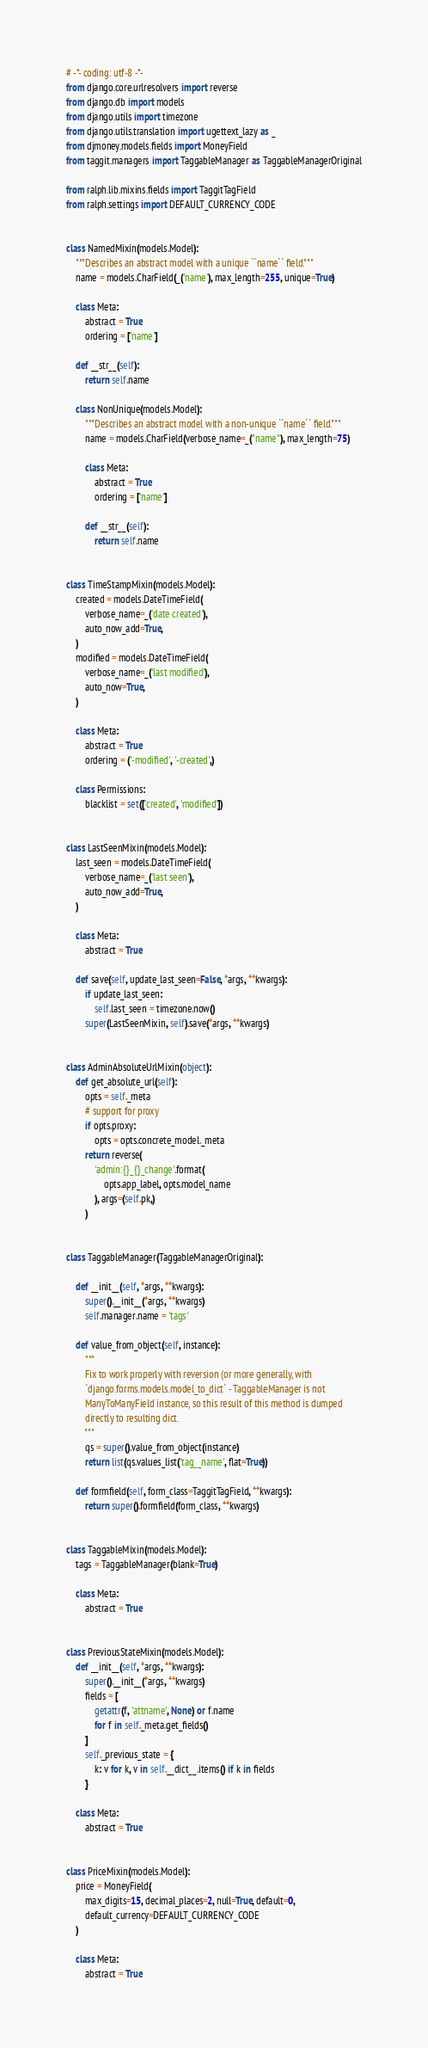<code> <loc_0><loc_0><loc_500><loc_500><_Python_># -*- coding: utf-8 -*-
from django.core.urlresolvers import reverse
from django.db import models
from django.utils import timezone
from django.utils.translation import ugettext_lazy as _
from djmoney.models.fields import MoneyField
from taggit.managers import TaggableManager as TaggableManagerOriginal

from ralph.lib.mixins.fields import TaggitTagField
from ralph.settings import DEFAULT_CURRENCY_CODE


class NamedMixin(models.Model):
    """Describes an abstract model with a unique ``name`` field."""
    name = models.CharField(_('name'), max_length=255, unique=True)

    class Meta:
        abstract = True
        ordering = ['name']

    def __str__(self):
        return self.name

    class NonUnique(models.Model):
        """Describes an abstract model with a non-unique ``name`` field."""
        name = models.CharField(verbose_name=_("name"), max_length=75)

        class Meta:
            abstract = True
            ordering = ['name']

        def __str__(self):
            return self.name


class TimeStampMixin(models.Model):
    created = models.DateTimeField(
        verbose_name=_('date created'),
        auto_now_add=True,
    )
    modified = models.DateTimeField(
        verbose_name=_('last modified'),
        auto_now=True,
    )

    class Meta:
        abstract = True
        ordering = ('-modified', '-created',)

    class Permissions:
        blacklist = set(['created', 'modified'])


class LastSeenMixin(models.Model):
    last_seen = models.DateTimeField(
        verbose_name=_('last seen'),
        auto_now_add=True,
    )

    class Meta:
        abstract = True

    def save(self, update_last_seen=False, *args, **kwargs):
        if update_last_seen:
            self.last_seen = timezone.now()
        super(LastSeenMixin, self).save(*args, **kwargs)


class AdminAbsoluteUrlMixin(object):
    def get_absolute_url(self):
        opts = self._meta
        # support for proxy
        if opts.proxy:
            opts = opts.concrete_model._meta
        return reverse(
            'admin:{}_{}_change'.format(
                opts.app_label, opts.model_name
            ), args=(self.pk,)
        )


class TaggableManager(TaggableManagerOriginal):

    def __init__(self, *args, **kwargs):
        super().__init__(*args, **kwargs)
        self.manager.name = 'tags'

    def value_from_object(self, instance):
        """
        Fix to work properly with reversion (or more generally, with
        `django.forms.models.model_to_dict` - TaggableManager is not
        ManyToManyField instance, so this result of this method is dumped
        directly to resulting dict.
        """
        qs = super().value_from_object(instance)
        return list(qs.values_list('tag__name', flat=True))

    def formfield(self, form_class=TaggitTagField, **kwargs):
        return super().formfield(form_class, **kwargs)


class TaggableMixin(models.Model):
    tags = TaggableManager(blank=True)

    class Meta:
        abstract = True


class PreviousStateMixin(models.Model):
    def __init__(self, *args, **kwargs):
        super().__init__(*args, **kwargs)
        fields = [
            getattr(f, 'attname', None) or f.name
            for f in self._meta.get_fields()
        ]
        self._previous_state = {
            k: v for k, v in self.__dict__.items() if k in fields
        }

    class Meta:
        abstract = True


class PriceMixin(models.Model):
    price = MoneyField(
        max_digits=15, decimal_places=2, null=True, default=0,
        default_currency=DEFAULT_CURRENCY_CODE
    )

    class Meta:
        abstract = True
</code> 